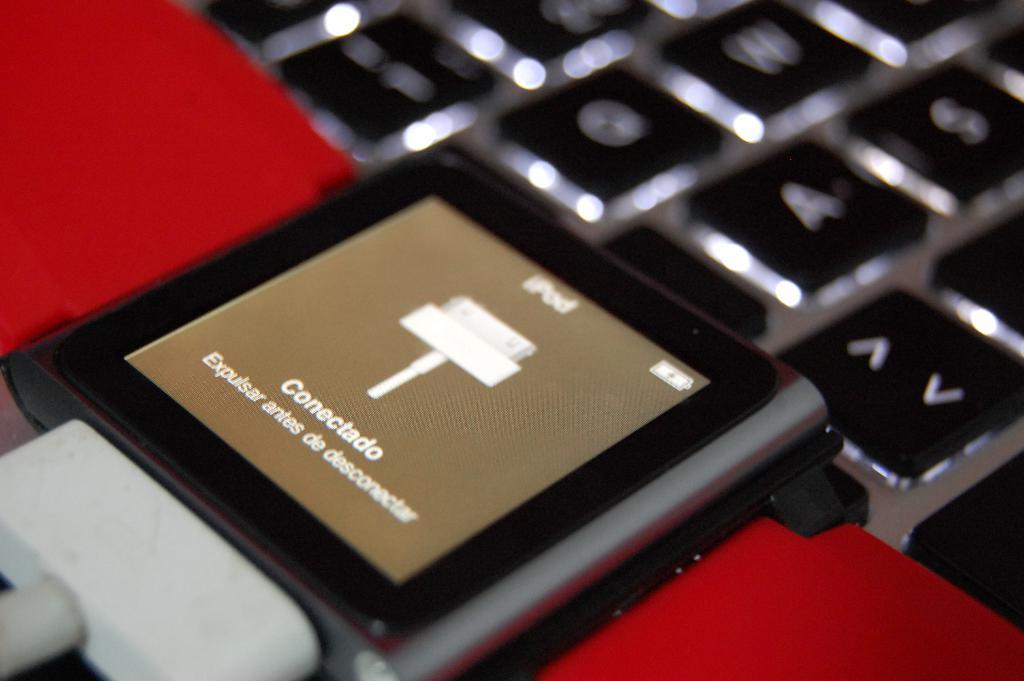What is the brand of the device?
Offer a very short reply. Ipod. 